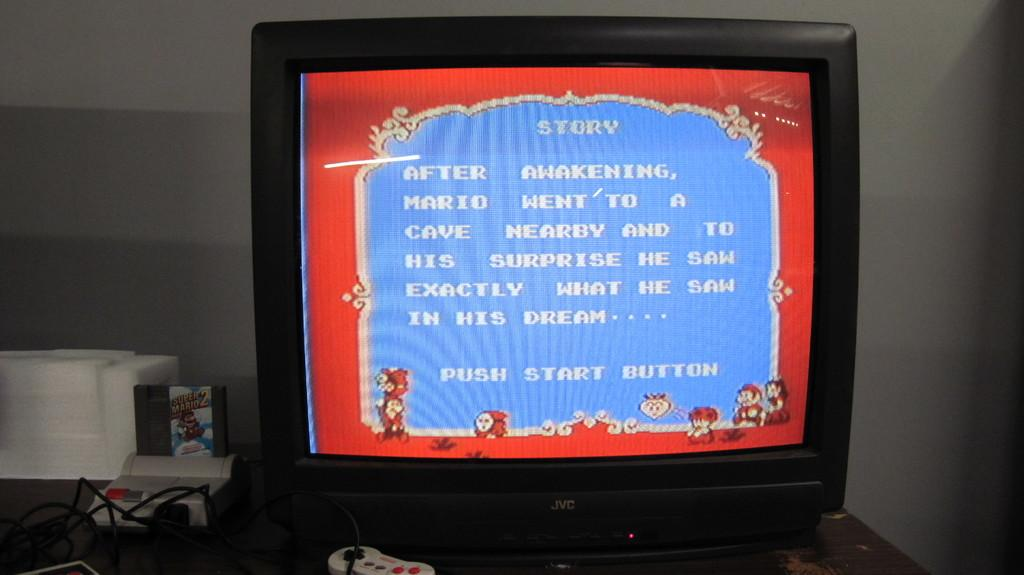Provide a one-sentence caption for the provided image. An old style computer sits next to a bulky monitor which displays arcade type text concerning the games story. 